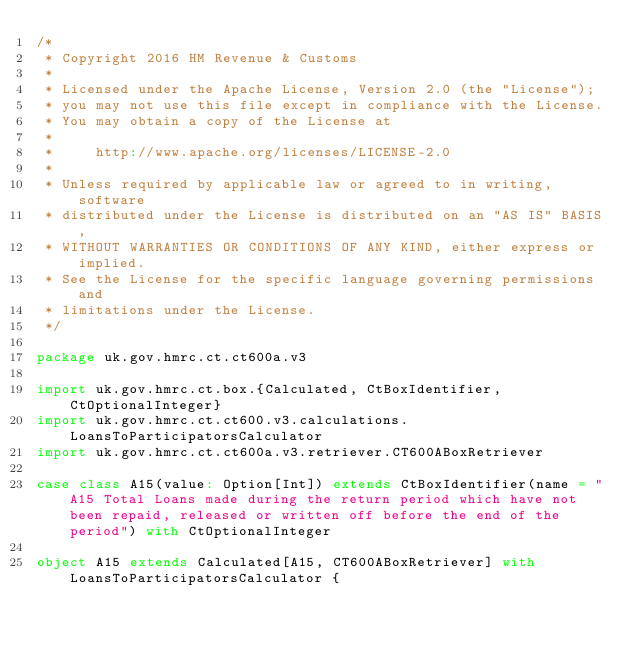Convert code to text. <code><loc_0><loc_0><loc_500><loc_500><_Scala_>/*
 * Copyright 2016 HM Revenue & Customs
 *
 * Licensed under the Apache License, Version 2.0 (the "License");
 * you may not use this file except in compliance with the License.
 * You may obtain a copy of the License at
 *
 *     http://www.apache.org/licenses/LICENSE-2.0
 *
 * Unless required by applicable law or agreed to in writing, software
 * distributed under the License is distributed on an "AS IS" BASIS,
 * WITHOUT WARRANTIES OR CONDITIONS OF ANY KIND, either express or implied.
 * See the License for the specific language governing permissions and
 * limitations under the License.
 */

package uk.gov.hmrc.ct.ct600a.v3

import uk.gov.hmrc.ct.box.{Calculated, CtBoxIdentifier, CtOptionalInteger}
import uk.gov.hmrc.ct.ct600.v3.calculations.LoansToParticipatorsCalculator
import uk.gov.hmrc.ct.ct600a.v3.retriever.CT600ABoxRetriever

case class A15(value: Option[Int]) extends CtBoxIdentifier(name = "A15 Total Loans made during the return period which have not been repaid, released or written off before the end of the period") with CtOptionalInteger

object A15 extends Calculated[A15, CT600ABoxRetriever] with LoansToParticipatorsCalculator {
</code> 